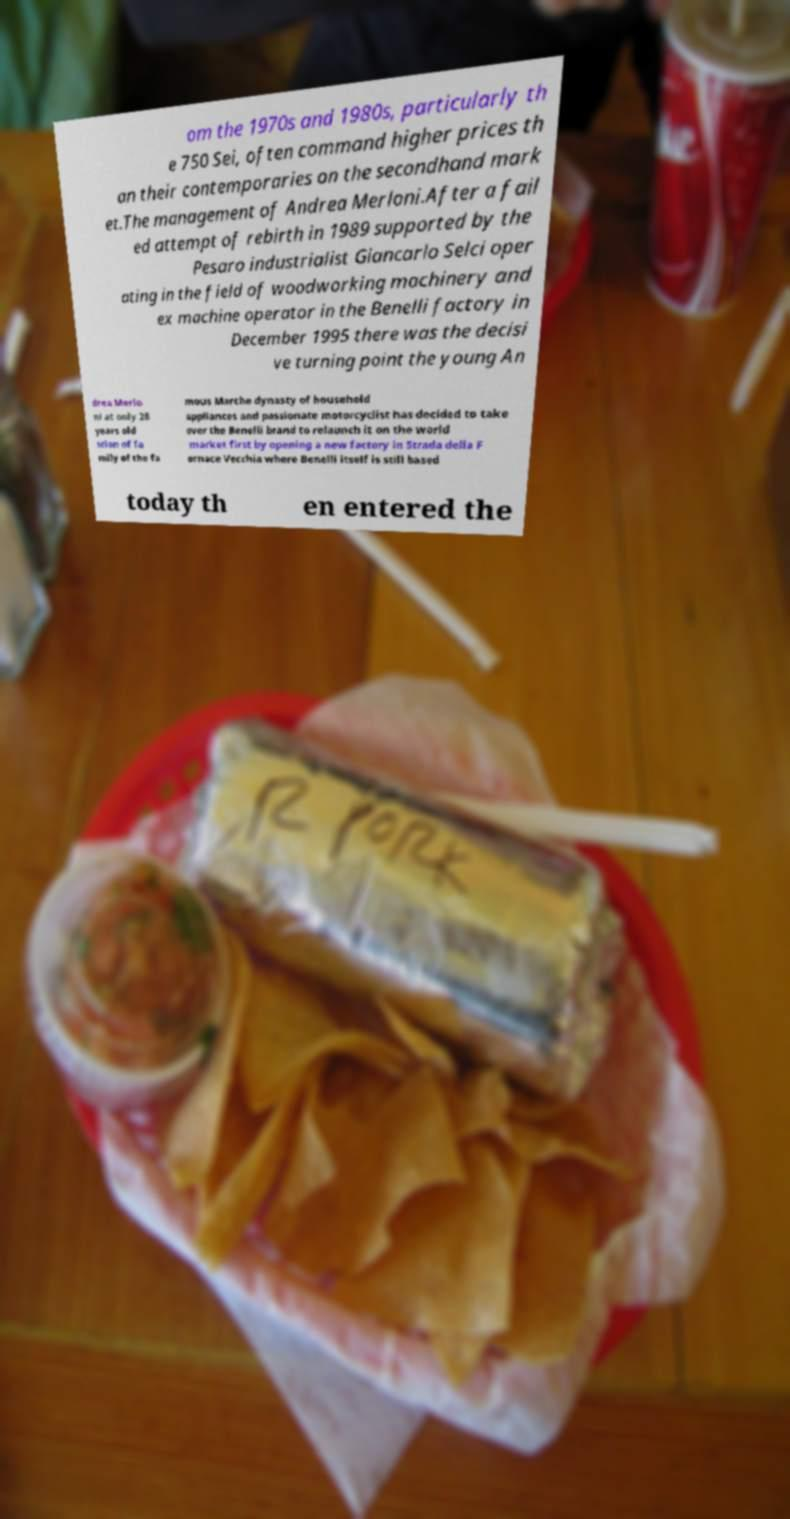Please identify and transcribe the text found in this image. om the 1970s and 1980s, particularly th e 750 Sei, often command higher prices th an their contemporaries on the secondhand mark et.The management of Andrea Merloni.After a fail ed attempt of rebirth in 1989 supported by the Pesaro industrialist Giancarlo Selci oper ating in the field of woodworking machinery and ex machine operator in the Benelli factory in December 1995 there was the decisi ve turning point the young An drea Merlo ni at only 28 years old scion of fa mily of the fa mous Marche dynasty of household appliances and passionate motorcyclist has decided to take over the Benelli brand to relaunch it on the world market first by opening a new factory in Strada della F ornace Vecchia where Benelli itself is still based today th en entered the 